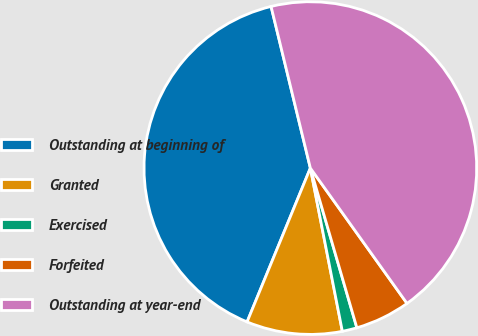Convert chart to OTSL. <chart><loc_0><loc_0><loc_500><loc_500><pie_chart><fcel>Outstanding at beginning of<fcel>Granted<fcel>Exercised<fcel>Forfeited<fcel>Outstanding at year-end<nl><fcel>39.99%<fcel>9.29%<fcel>1.43%<fcel>5.36%<fcel>43.92%<nl></chart> 